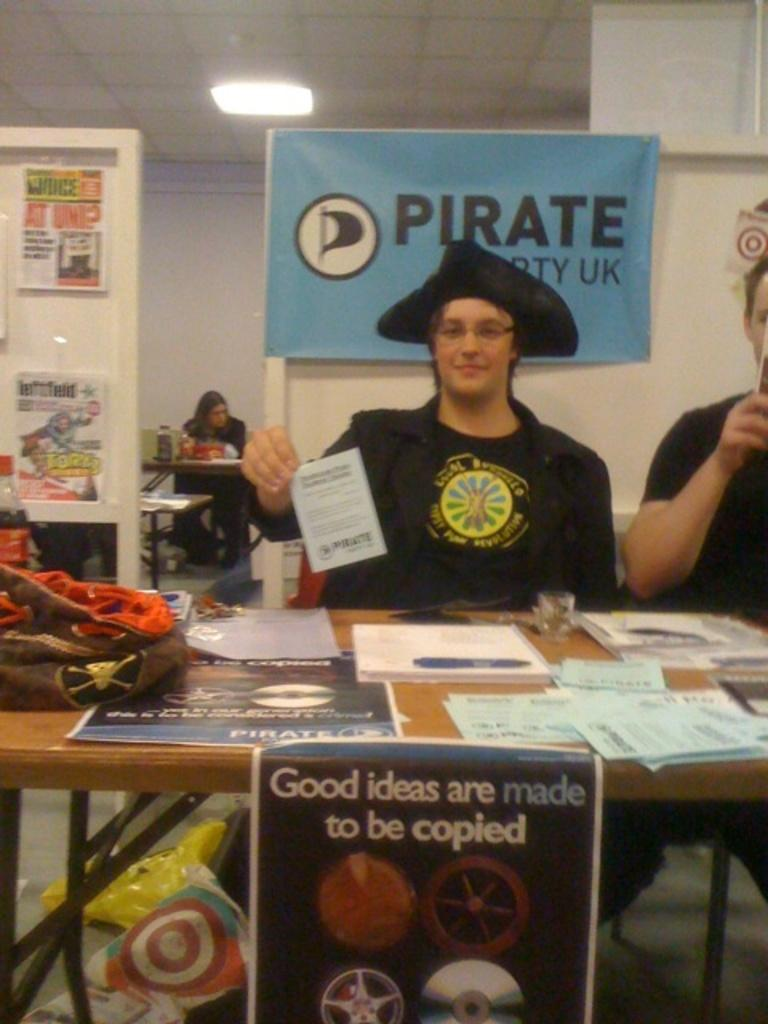Provide a one-sentence caption for the provided image. A boy is dressed as a pirate at a table under a sign that says Pirate Party UK. 